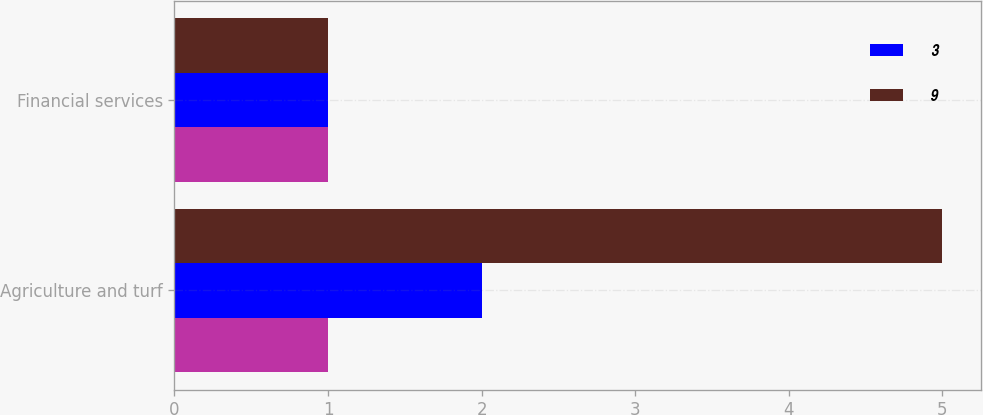Convert chart to OTSL. <chart><loc_0><loc_0><loc_500><loc_500><stacked_bar_chart><ecel><fcel>Agriculture and turf<fcel>Financial services<nl><fcel>nan<fcel>1<fcel>1<nl><fcel>3<fcel>2<fcel>1<nl><fcel>9<fcel>5<fcel>1<nl></chart> 